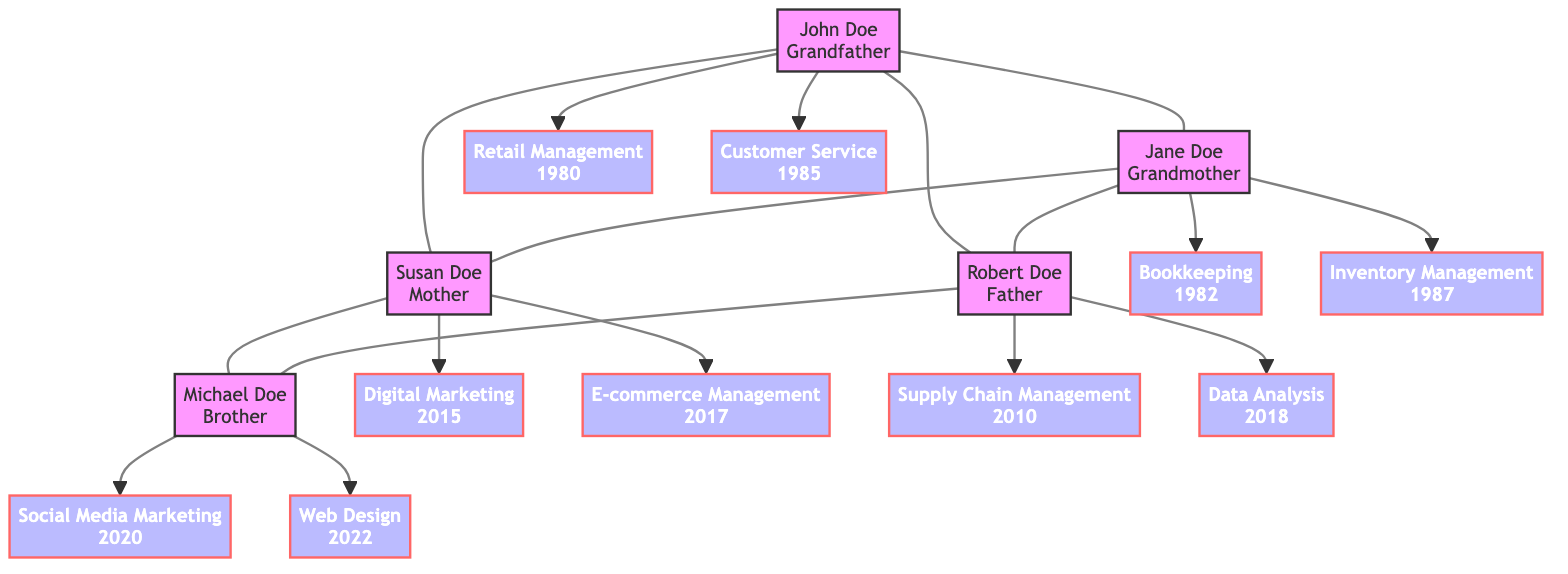What skills did John Doe acquire in 1980? John Doe has two skills listed. The skill acquired in 1980 is "Retail Management," as seen in the diagram linked to John Doe.
Answer: Retail Management Which family member has training in E-commerce Management? The diagram shows that Susan Doe is connected to the skill "E-commerce Management," which indicates that she is the one who attended the corresponding training program.
Answer: Susan Doe How many skills did Jane Doe develop? By counting the skills linked to Jane Doe in the diagram, we find there are two: "Bookkeeping" and "Inventory Management." Thus, the total number of skills is two.
Answer: 2 Which family member completed their training in Digital Marketing? From the diagram, we can see that Susan Doe is associated with "Digital Marketing," indicating she completed this training program.
Answer: Susan Doe What year did Robert Doe complete his Data Analysis training? The diagram indicates Robert Doe's connection to "Data Analysis," which shows that he completed this training in the year 2018.
Answer: 2018 Which training program did Michael Doe undertake for Web Design? Looking at the skills linked to Michael Doe, we find the skill "Web Design," which is tied to the training program "Web Design for Everybody from University of Michigan," indicating the program he undertook.
Answer: Web Design for Everybody from University of Michigan Who is the only family member with training in Supply Chain Management? The diagram indicates that only Robert Doe is associated with the skill "Supply Chain Management," showing that he is the only family member with this specific training.
Answer: Robert Doe How many members of the family are listed in total? The diagram shows five family members present: John Doe, Jane Doe, Susan Doe, Robert Doe, and Michael Doe. Counting these gives us a total of five family members.
Answer: 5 What common training program did both parents, Susan Doe and Robert Doe, attend that is related to management? The diagram highlights that both parents have training programs related to management: Susan Doe with "Digital Marketing" and Robert Doe with "Supply Chain Management." However, no specific common program is noted; rather, they possess different management skills linking them to management areas.
Answer: No common program 